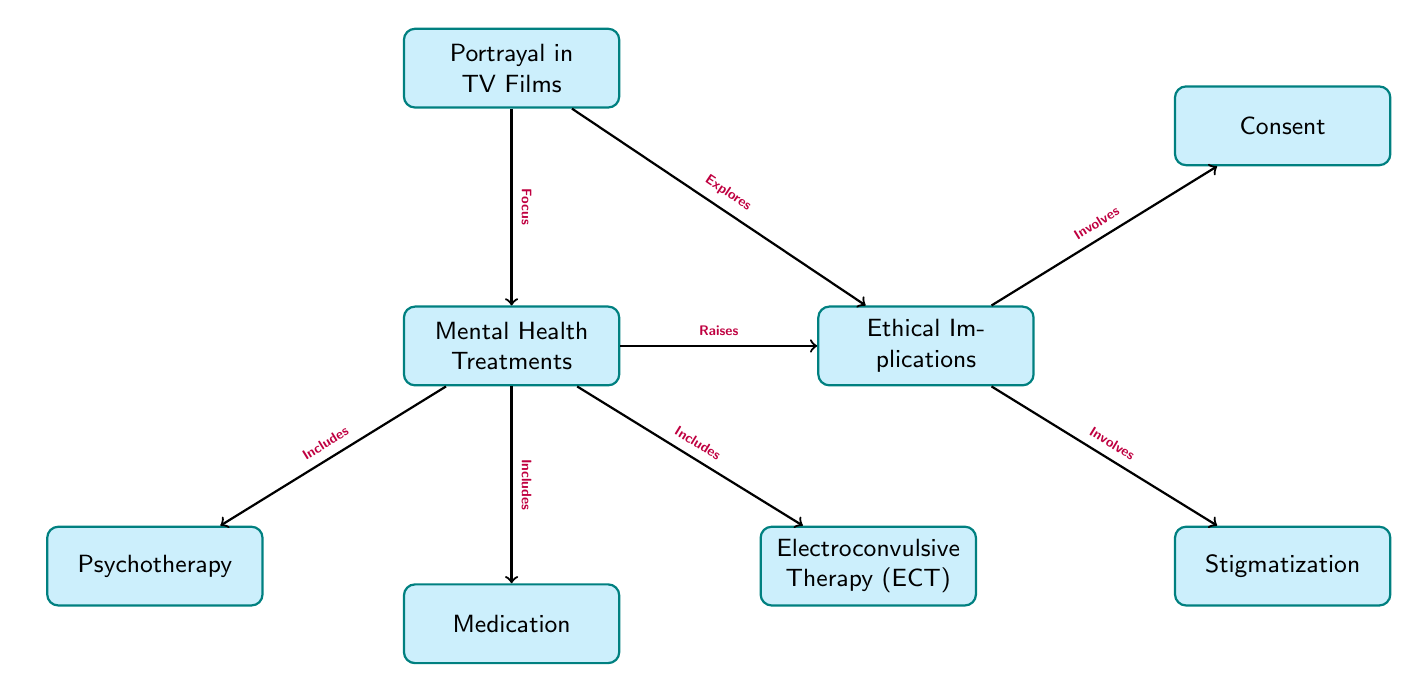What are the three main types of mental health treatments depicted in the diagram? The diagram includes three explicit nodes for mental health treatments: Psychotherapy, Medication, and Electroconvulsive Therapy (ECT).
Answer: Psychotherapy, Medication, Electroconvulsive Therapy (ECT) What node is connected to Ethical Implications that involves consent? The node "Consent" is connected to "Ethical Implications" with the edge labeled "Involves". This indicates that consent is a component of the ethical considerations related to mental health treatments.
Answer: Consent How many types of mental health treatments are identified in the diagram? The diagram visually illustrates three distinct categories of mental health treatments: Psychotherapy, Medication, and Electroconvulsive Therapy (ECT).
Answer: Three Which node in the diagram explores ethical implications? The node that explores ethical implications is the "Portrayal in TV Films" node, which connects to "Ethical Implications" with the edge labeled "Explores". This denotes that the portrayal in TV films delves into the ethical aspects surrounding mental health treatments.
Answer: Portrayal in TV Films What type of relationship is shown between Mental Health Treatments and Ethical Implications? The relationship between "Mental Health Treatments" and "Ethical Implications" is indicated by the edge labeled "Raises". This suggests that the implementation of mental health treatments brings forth ethical questions and issues.
Answer: Raises 